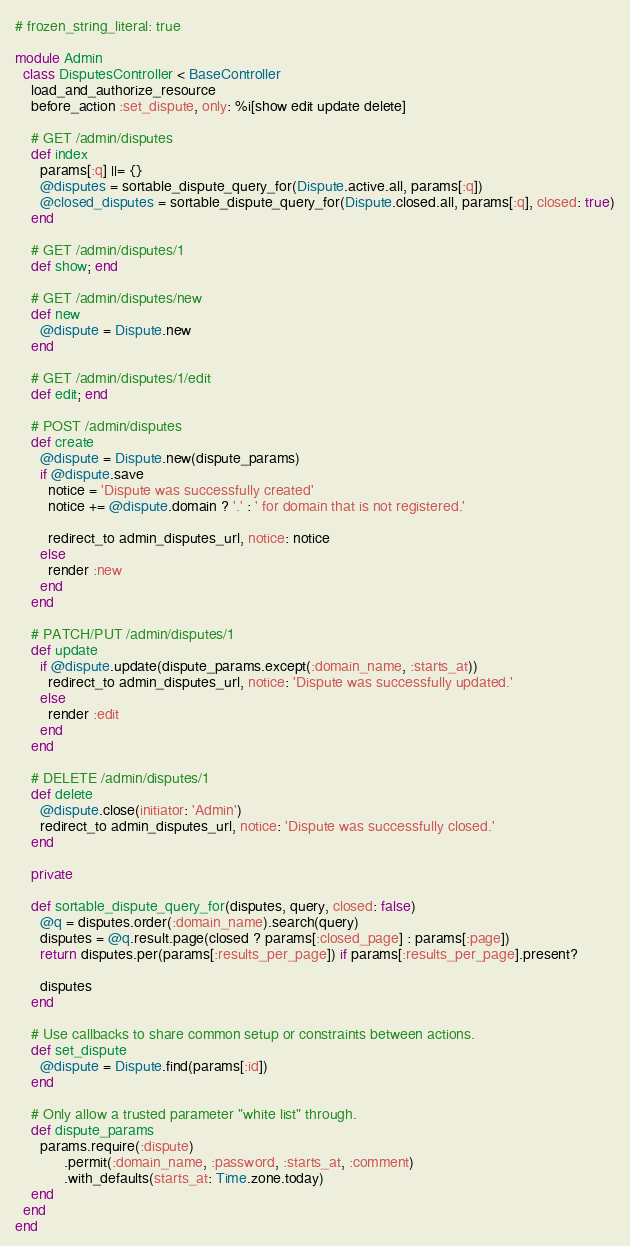<code> <loc_0><loc_0><loc_500><loc_500><_Ruby_># frozen_string_literal: true

module Admin
  class DisputesController < BaseController
    load_and_authorize_resource
    before_action :set_dispute, only: %i[show edit update delete]

    # GET /admin/disputes
    def index
      params[:q] ||= {}
      @disputes = sortable_dispute_query_for(Dispute.active.all, params[:q])
      @closed_disputes = sortable_dispute_query_for(Dispute.closed.all, params[:q], closed: true)
    end

    # GET /admin/disputes/1
    def show; end

    # GET /admin/disputes/new
    def new
      @dispute = Dispute.new
    end

    # GET /admin/disputes/1/edit
    def edit; end

    # POST /admin/disputes
    def create
      @dispute = Dispute.new(dispute_params)
      if @dispute.save
        notice = 'Dispute was successfully created'
        notice += @dispute.domain ? '.' : ' for domain that is not registered.'

        redirect_to admin_disputes_url, notice: notice
      else
        render :new
      end
    end

    # PATCH/PUT /admin/disputes/1
    def update
      if @dispute.update(dispute_params.except(:domain_name, :starts_at))
        redirect_to admin_disputes_url, notice: 'Dispute was successfully updated.'
      else
        render :edit
      end
    end

    # DELETE /admin/disputes/1
    def delete
      @dispute.close(initiator: 'Admin')
      redirect_to admin_disputes_url, notice: 'Dispute was successfully closed.'
    end

    private

    def sortable_dispute_query_for(disputes, query, closed: false)
      @q = disputes.order(:domain_name).search(query)
      disputes = @q.result.page(closed ? params[:closed_page] : params[:page])
      return disputes.per(params[:results_per_page]) if params[:results_per_page].present?

      disputes
    end

    # Use callbacks to share common setup or constraints between actions.
    def set_dispute
      @dispute = Dispute.find(params[:id])
    end

    # Only allow a trusted parameter "white list" through.
    def dispute_params
      params.require(:dispute)
            .permit(:domain_name, :password, :starts_at, :comment)
            .with_defaults(starts_at: Time.zone.today)
    end
  end
end
</code> 